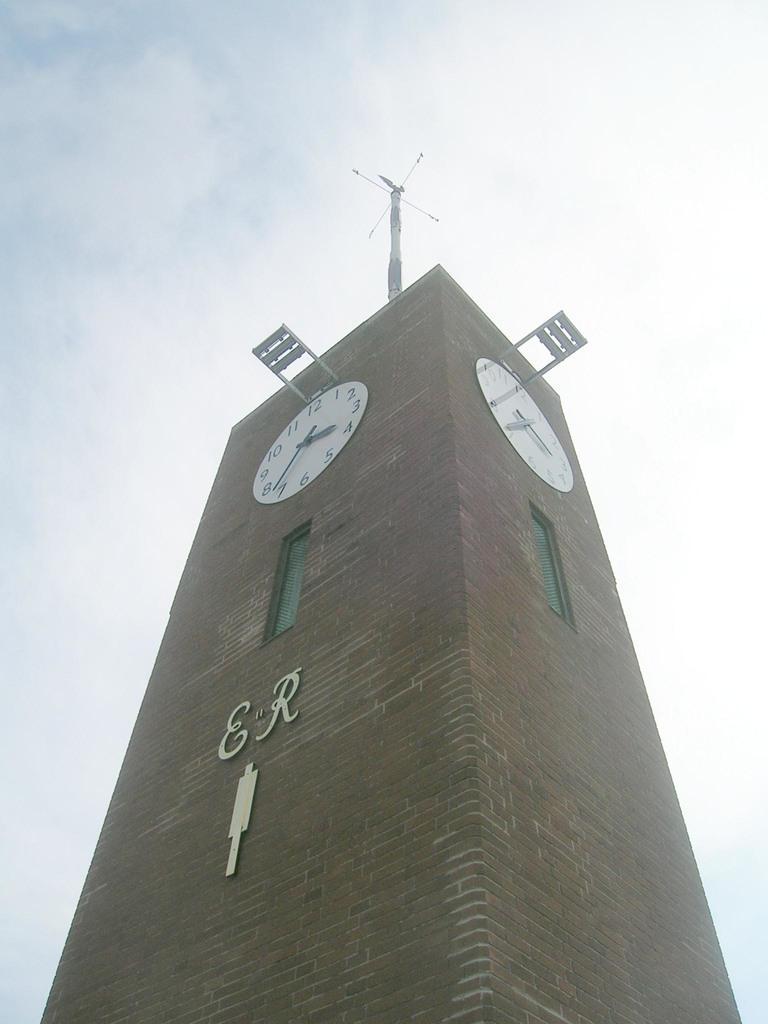Could you give a brief overview of what you see in this image? In this image in the center there is a tower, and there are clocks and there is text and antenna. In the background there is sky. 